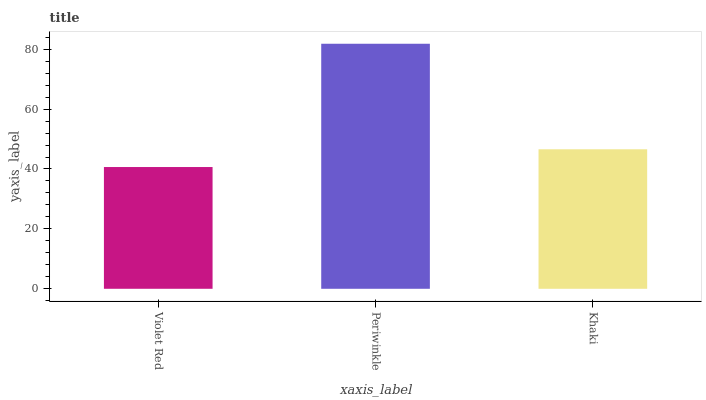Is Khaki the minimum?
Answer yes or no. No. Is Khaki the maximum?
Answer yes or no. No. Is Periwinkle greater than Khaki?
Answer yes or no. Yes. Is Khaki less than Periwinkle?
Answer yes or no. Yes. Is Khaki greater than Periwinkle?
Answer yes or no. No. Is Periwinkle less than Khaki?
Answer yes or no. No. Is Khaki the high median?
Answer yes or no. Yes. Is Khaki the low median?
Answer yes or no. Yes. Is Periwinkle the high median?
Answer yes or no. No. Is Violet Red the low median?
Answer yes or no. No. 